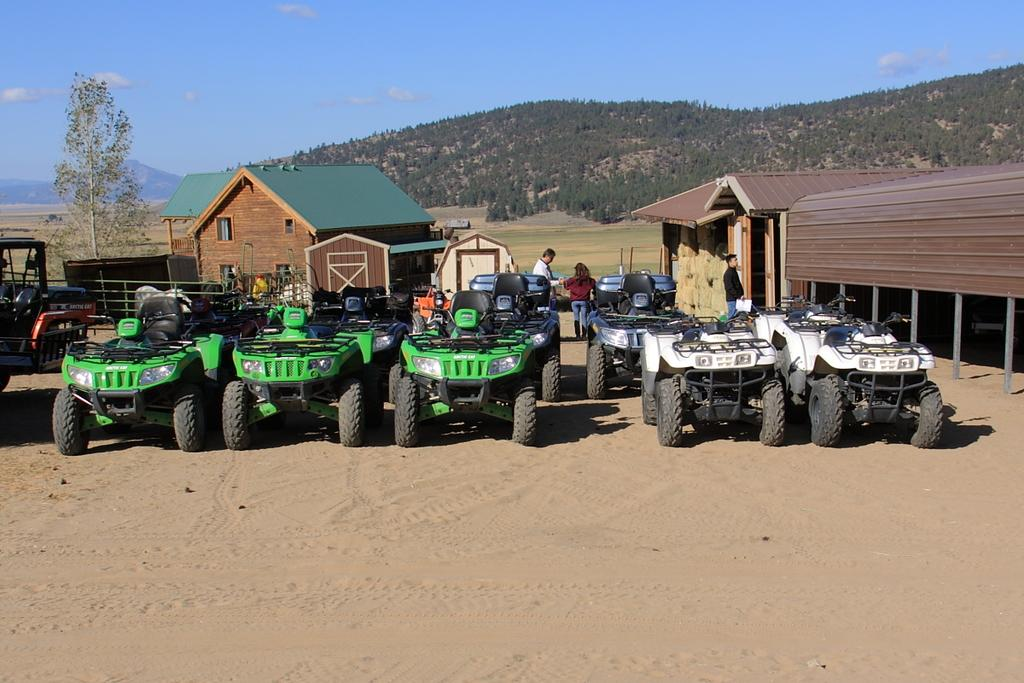What types of objects can be seen in the image? There are vehicles, houses, and trees in the image. Are there any living beings present in the image? Yes, there are people standing on the ground in the image. What is visible in the background of the image? The sky is visible in the background of the image. Where is the table located in the image? There is no table present in the image. Can you see any ants crawling on the people in the image? There are no ants visible in the image. 